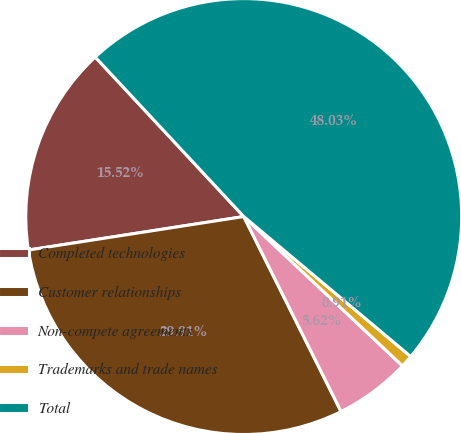<chart> <loc_0><loc_0><loc_500><loc_500><pie_chart><fcel>Completed technologies<fcel>Customer relationships<fcel>Non-compete agreements<fcel>Trademarks and trade names<fcel>Total<nl><fcel>15.52%<fcel>29.91%<fcel>5.62%<fcel>0.91%<fcel>48.03%<nl></chart> 